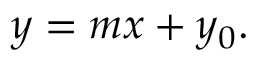<formula> <loc_0><loc_0><loc_500><loc_500>y = m x + y _ { 0 } .</formula> 